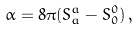Convert formula to latex. <formula><loc_0><loc_0><loc_500><loc_500>\alpha = 8 \pi ( S _ { a } ^ { a } - S _ { 0 } ^ { 0 } ) \, ,</formula> 